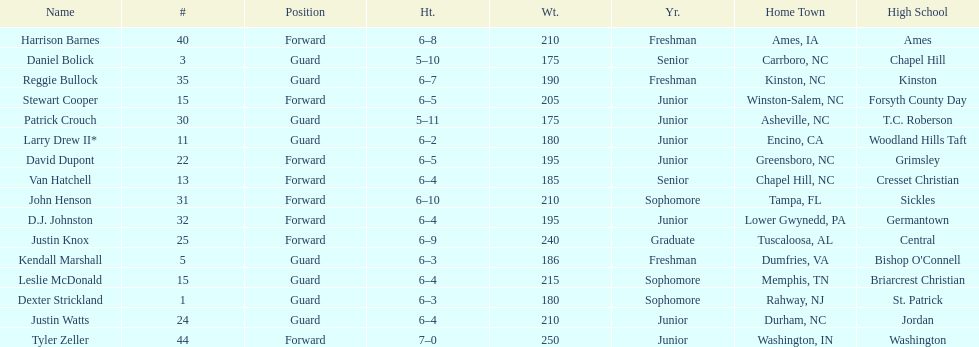What was the number of freshmen on the team? 3. 